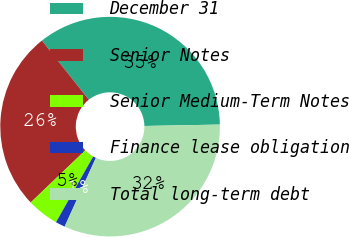Convert chart. <chart><loc_0><loc_0><loc_500><loc_500><pie_chart><fcel>December 31<fcel>Senior Notes<fcel>Senior Medium-Term Notes<fcel>Finance lease obligation<fcel>Total long-term debt<nl><fcel>35.36%<fcel>26.48%<fcel>4.67%<fcel>1.4%<fcel>32.09%<nl></chart> 